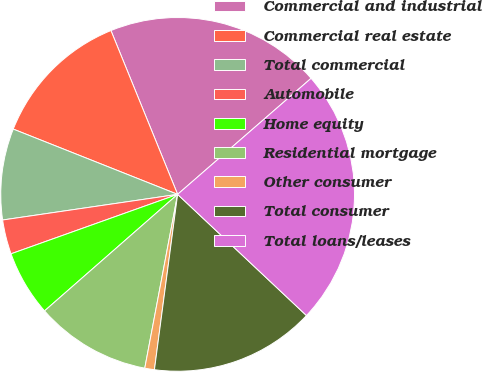Convert chart to OTSL. <chart><loc_0><loc_0><loc_500><loc_500><pie_chart><fcel>Commercial and industrial<fcel>Commercial real estate<fcel>Total commercial<fcel>Automobile<fcel>Home equity<fcel>Residential mortgage<fcel>Other consumer<fcel>Total consumer<fcel>Total loans/leases<nl><fcel>19.76%<fcel>12.83%<fcel>8.33%<fcel>3.14%<fcel>5.99%<fcel>10.58%<fcel>0.88%<fcel>15.08%<fcel>23.4%<nl></chart> 